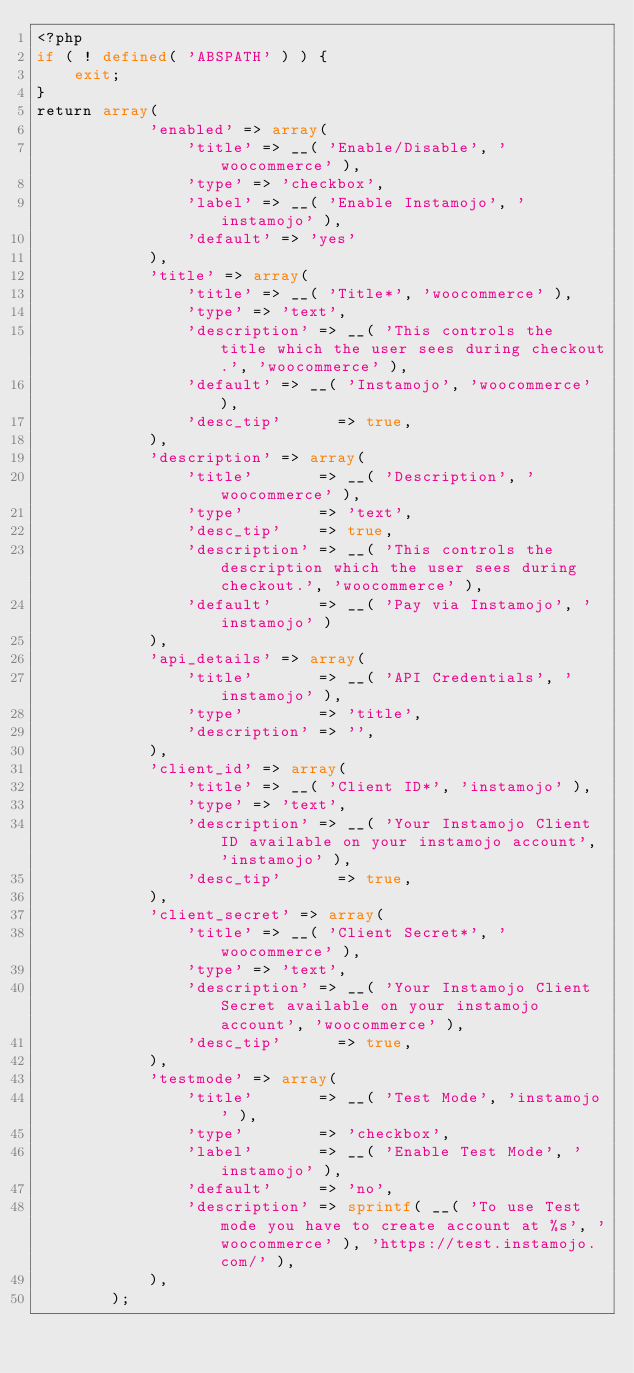Convert code to text. <code><loc_0><loc_0><loc_500><loc_500><_PHP_><?php 
if ( ! defined( 'ABSPATH' ) ) {
	exit;
}
return array(
			'enabled' => array(
				'title' => __( 'Enable/Disable', 'woocommerce' ),
				'type' => 'checkbox',
				'label' => __( 'Enable Instamojo', 'instamojo' ),
				'default' => 'yes'
			),
			'title' => array(
				'title' => __( 'Title*', 'woocommerce' ),
				'type' => 'text',
				'description' => __( 'This controls the title which the user sees during checkout.', 'woocommerce' ),
				'default' => __( 'Instamojo', 'woocommerce' ),
				'desc_tip'      => true,
			),
			'description' => array(
				'title'       => __( 'Description', 'woocommerce' ),
				'type'        => 'text',
				'desc_tip'    => true,
				'description' => __( 'This controls the description which the user sees during checkout.', 'woocommerce' ),
				'default'     => __( 'Pay via Instamojo', 'instamojo' )
			),
			'api_details' => array(
				'title'       => __( 'API Credentials', 'instamojo' ),
				'type'        => 'title',
				'description' => '',
			),
			'client_id' => array(
				'title' => __( 'Client ID*', 'instamojo' ),
				'type' => 'text',
				'description' => __( 'Your Instamojo Client ID available on your instamojo account', 'instamojo' ),
				'desc_tip'      => true,
			),
			'client_secret' => array(
				'title' => __( 'Client Secret*', 'woocommerce' ),
				'type' => 'text',
				'description' => __( 'Your Instamojo Client Secret available on your instamojo account', 'woocommerce' ),
				'desc_tip'      => true,
			),
			'testmode' => array(
				'title'       => __( 'Test Mode', 'instamojo' ),
				'type'        => 'checkbox',
				'label'       => __( 'Enable Test Mode', 'instamojo' ),
				'default'     => 'no',
				'description' => sprintf( __( 'To use Test mode you have to create account at %s', 'woocommerce' ), 'https://test.instamojo.com/' ),
			),		
		);</code> 